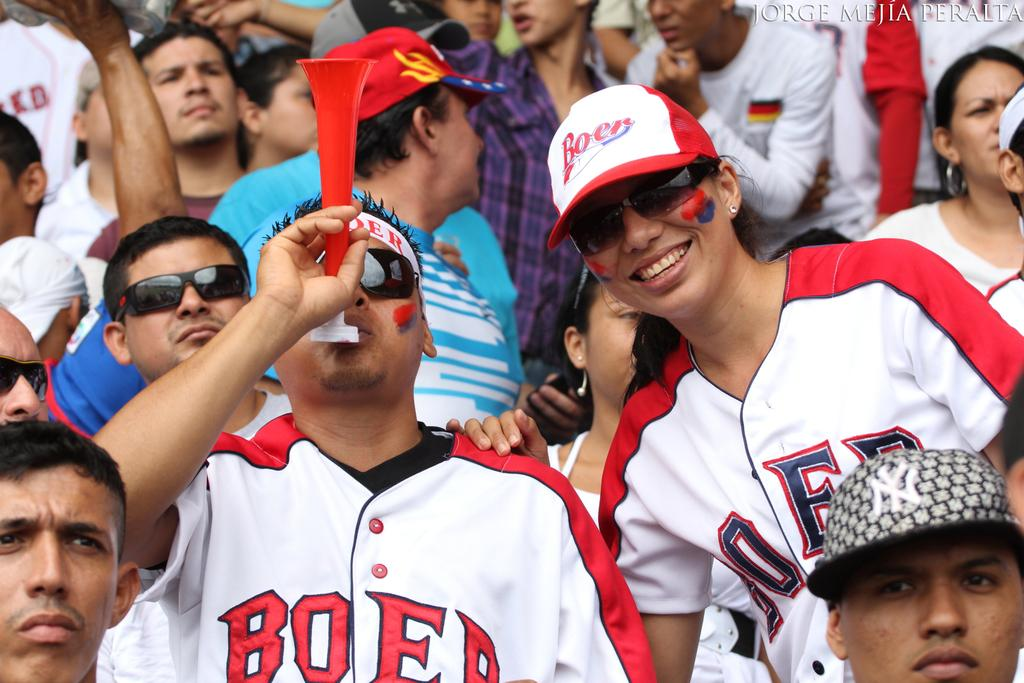<image>
Summarize the visual content of the image. fans in a stadium wear BOER jerseys and hats 